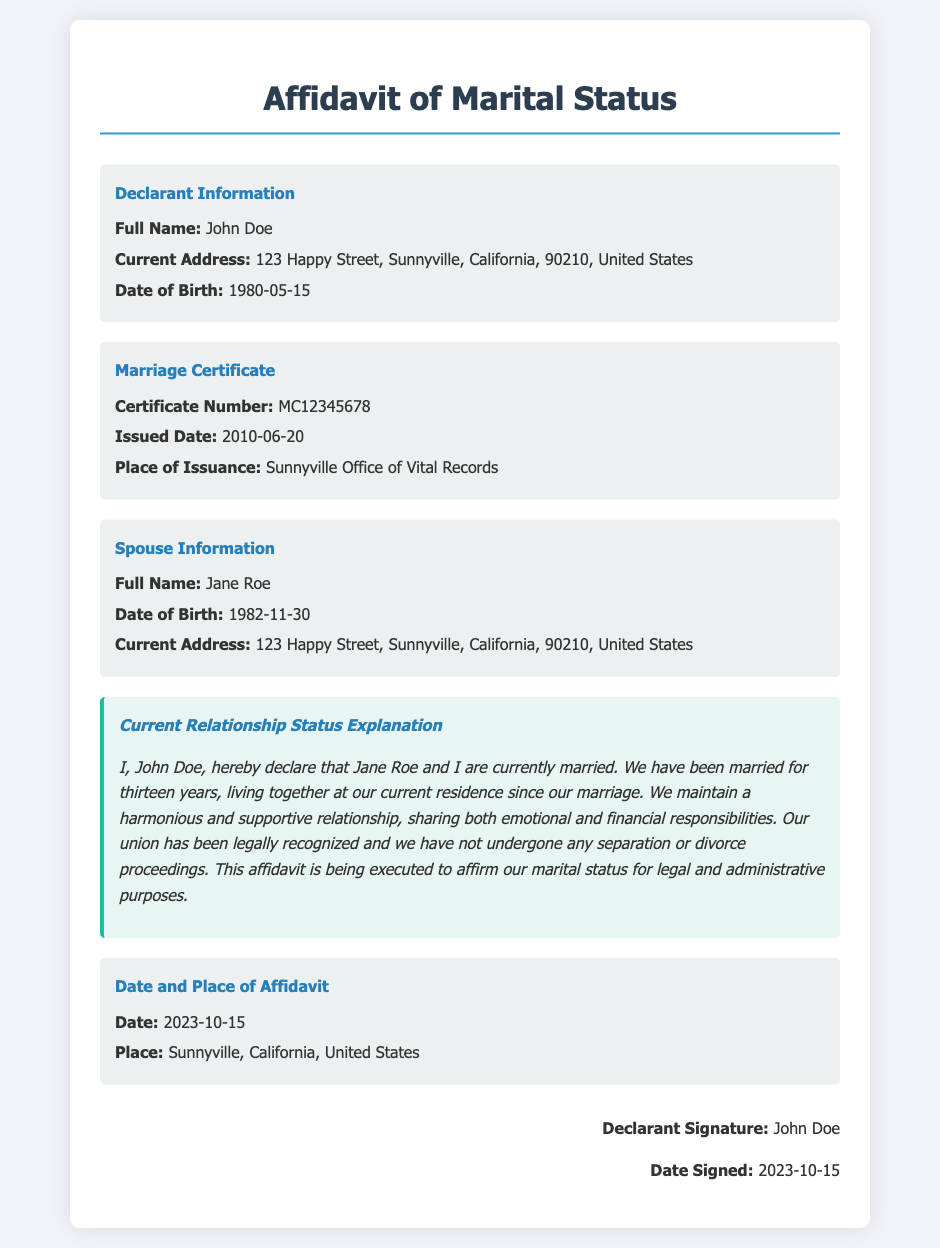What is the declarant's full name? The declarant's full name is listed in the document under Declarant Information.
Answer: John Doe What is the marriage certificate number? The marriage certificate number can be found in the Marriage Certificate section of the document.
Answer: MC12345678 When was the marriage certificate issued? The issued date for the marriage certificate is provided in the same section.
Answer: 2010-06-20 Who is the declarant's spouse? The spouse's full name is detailed in the Spouse Information section.
Answer: Jane Roe How long have John Doe and Jane Roe been married? The current relationship status explanation states how many years they have been married.
Answer: Thirteen years What is the current address of the declarant? The current address is mentioned in the Declarant Information section of the document.
Answer: 123 Happy Street, Sunnyville, California, 90210, United States When was the affidavit signed? The date signed is found in the signature section of the document.
Answer: 2023-10-15 What is the purpose of this affidavit? The purpose of the affidavit is mentioned in the Current Relationship Status Explanation.
Answer: To affirm marital status for legal and administrative purposes Where was the affidavit executed? The place of execution is provided in the Date and Place of Affidavit section.
Answer: Sunnyville, California, United States 